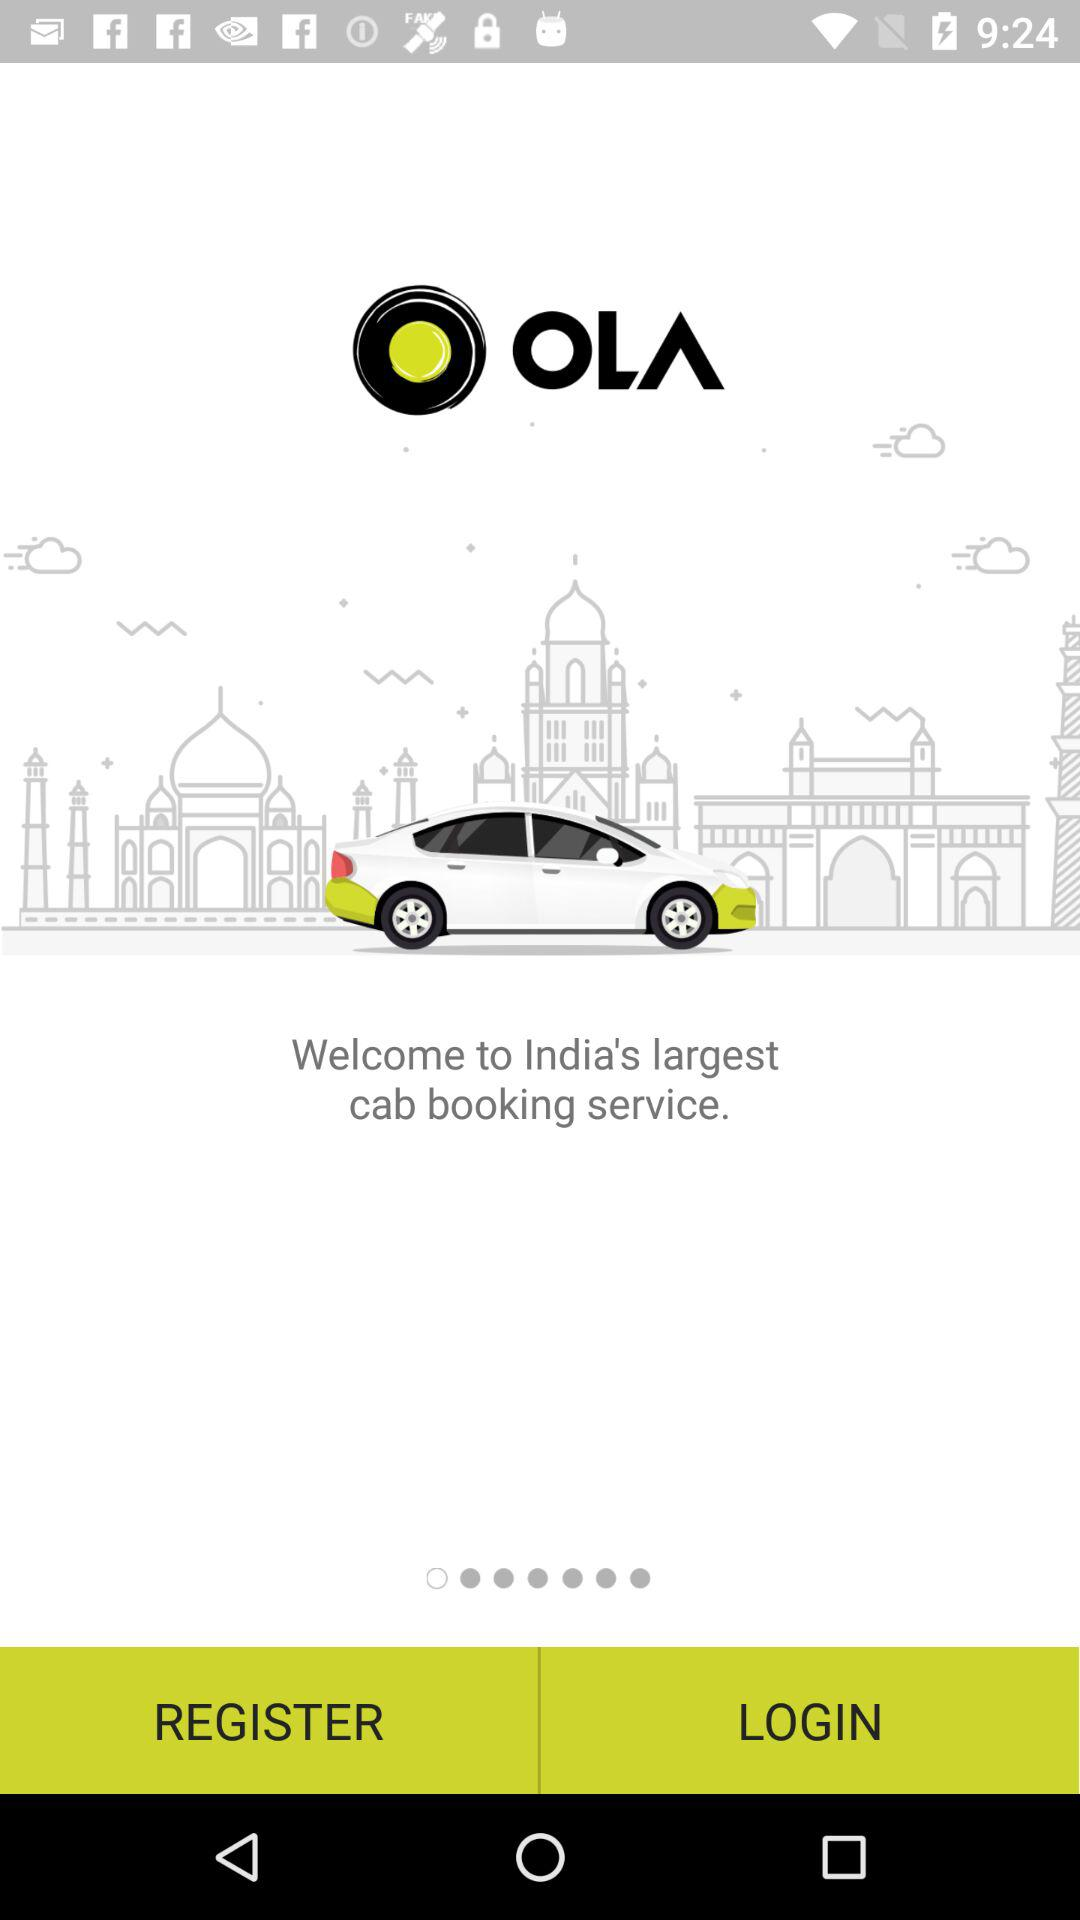Is a personal email address required to register?
When the provided information is insufficient, respond with <no answer>. <no answer> 